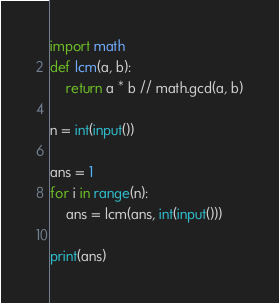Convert code to text. <code><loc_0><loc_0><loc_500><loc_500><_Python_>import math 
def lcm(a, b):
    return a * b // math.gcd(a, b)

n = int(input())

ans = 1
for i in range(n):
    ans = lcm(ans, int(input()))

print(ans)</code> 